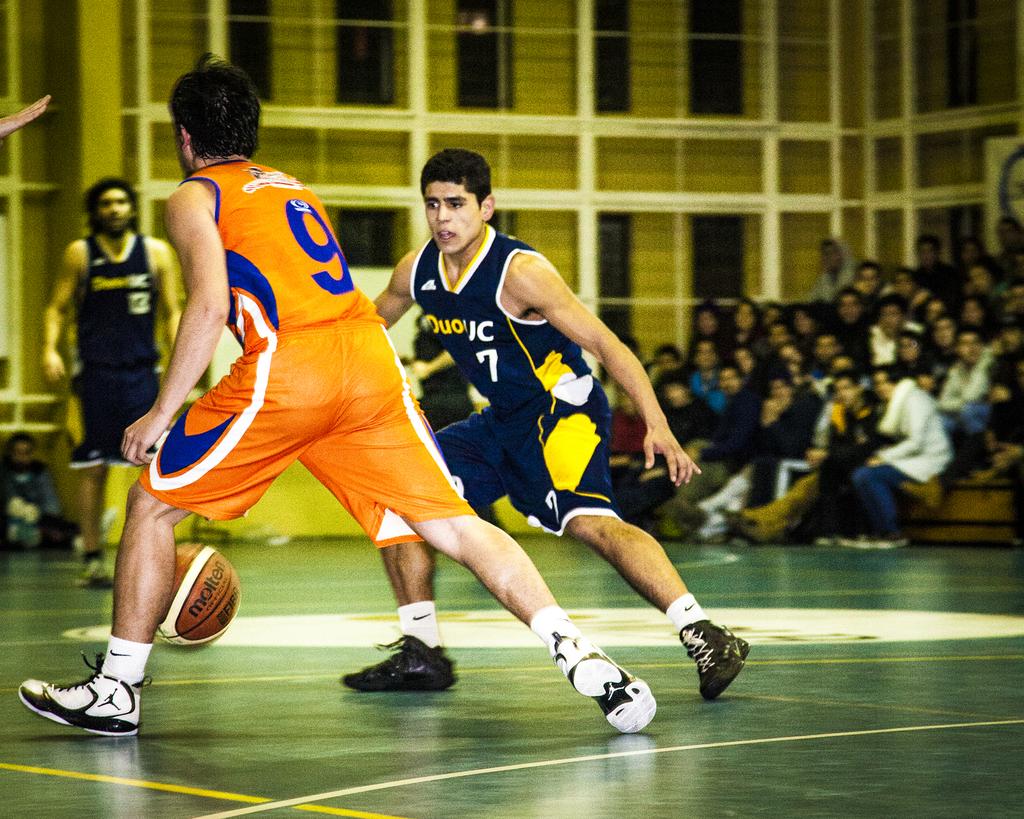What number is on the back of the orange jersey?
Give a very brief answer. 9. 